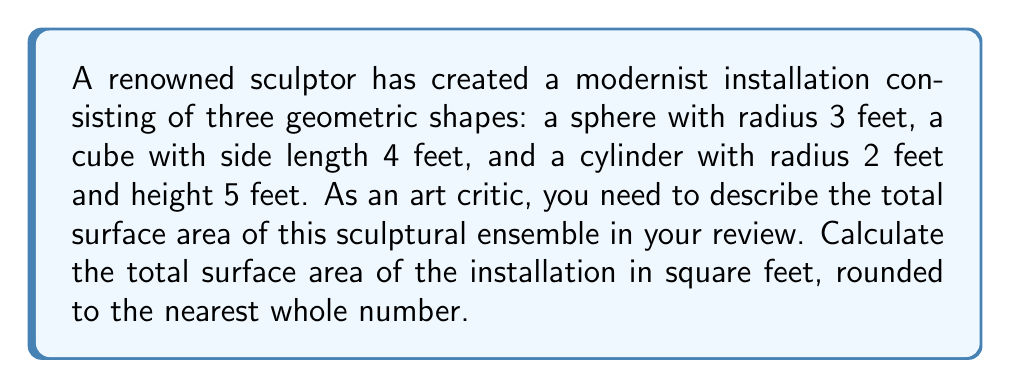Could you help me with this problem? Let's calculate the surface area of each shape individually:

1. Sphere:
   Surface area of a sphere = $4\pi r^2$
   $A_{sphere} = 4\pi(3)^2 = 36\pi$ sq ft

2. Cube:
   Surface area of a cube = $6s^2$, where s is the side length
   $A_{cube} = 6(4)^2 = 96$ sq ft

3. Cylinder:
   Surface area of a cylinder = $2\pi r^2 + 2\pi rh$
   $A_{cylinder} = 2\pi(2)^2 + 2\pi(2)(5) = 8\pi + 20\pi = 28\pi$ sq ft

Now, let's sum up the surface areas:
$$A_{total} = A_{sphere} + A_{cube} + A_{cylinder}$$
$$A_{total} = 36\pi + 96 + 28\pi$$
$$A_{total} = 64\pi + 96$$

To evaluate this:
$$A_{total} = 64(3.14159...) + 96 \approx 201.06 + 96 = 297.06$$

Rounding to the nearest whole number:
$$A_{total} \approx 297 \text{ sq ft}$$
Answer: 297 sq ft 